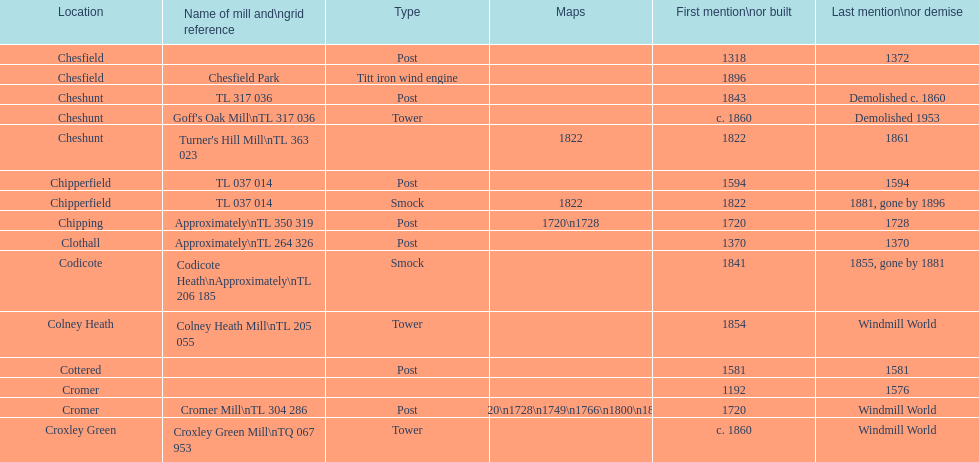What is the total number of mills named cheshunt? 3. 